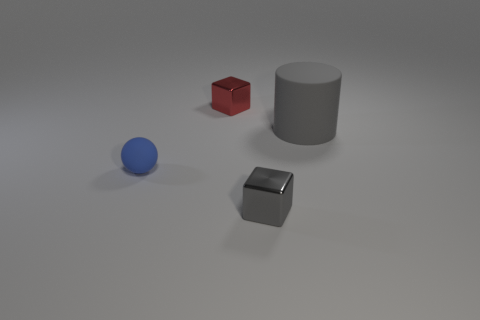Add 3 big matte cylinders. How many objects exist? 7 Subtract all balls. How many objects are left? 3 Subtract 0 brown cylinders. How many objects are left? 4 Subtract all tiny purple metal cubes. Subtract all tiny red metallic blocks. How many objects are left? 3 Add 4 tiny metallic objects. How many tiny metallic objects are left? 6 Add 3 tiny matte things. How many tiny matte things exist? 4 